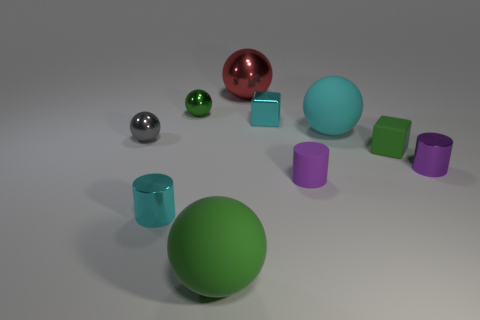Subtract all cyan cylinders. How many cylinders are left? 2 How many purple cylinders must be subtracted to get 1 purple cylinders? 1 Subtract all cubes. How many objects are left? 8 Subtract all cyan cubes. Subtract all cyan cylinders. How many cubes are left? 1 Subtract all yellow spheres. How many cyan cylinders are left? 1 Subtract all big objects. Subtract all cyan rubber balls. How many objects are left? 6 Add 8 small cyan cubes. How many small cyan cubes are left? 9 Add 2 tiny gray matte cubes. How many tiny gray matte cubes exist? 2 Subtract all cyan cylinders. How many cylinders are left? 2 Subtract 0 yellow balls. How many objects are left? 10 